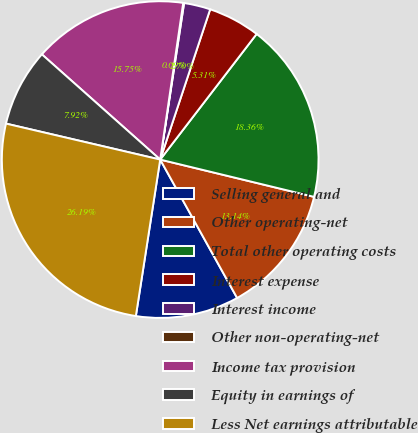Convert chart to OTSL. <chart><loc_0><loc_0><loc_500><loc_500><pie_chart><fcel>Selling general and<fcel>Other operating-net<fcel>Total other operating costs<fcel>Interest expense<fcel>Interest income<fcel>Other non-operating-net<fcel>Income tax provision<fcel>Equity in earnings of<fcel>Less Net earnings attributable<nl><fcel>10.53%<fcel>13.14%<fcel>18.36%<fcel>5.31%<fcel>2.7%<fcel>0.09%<fcel>15.75%<fcel>7.92%<fcel>26.19%<nl></chart> 